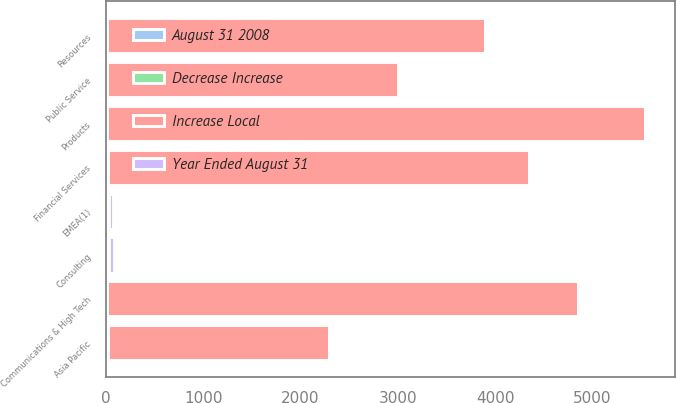Convert chart to OTSL. <chart><loc_0><loc_0><loc_500><loc_500><stacked_bar_chart><ecel><fcel>Communications & High Tech<fcel>Financial Services<fcel>Products<fcel>Public Service<fcel>Resources<fcel>EMEA(1)<fcel>Asia Pacific<fcel>Consulting<nl><fcel>Increase Local<fcel>4831<fcel>4323<fcel>5530<fcel>2984<fcel>3880<fcel>13<fcel>2270<fcel>13<nl><fcel>Decrease Increase<fcel>11<fcel>14<fcel>9<fcel>4<fcel>2<fcel>14<fcel>7<fcel>11<nl><fcel>August 31 2008<fcel>4<fcel>6<fcel>1<fcel>11<fcel>8<fcel>2<fcel>12<fcel>4<nl><fcel>Year Ended August 31<fcel>22<fcel>20<fcel>26<fcel>14<fcel>18<fcel>46<fcel>10<fcel>58<nl></chart> 